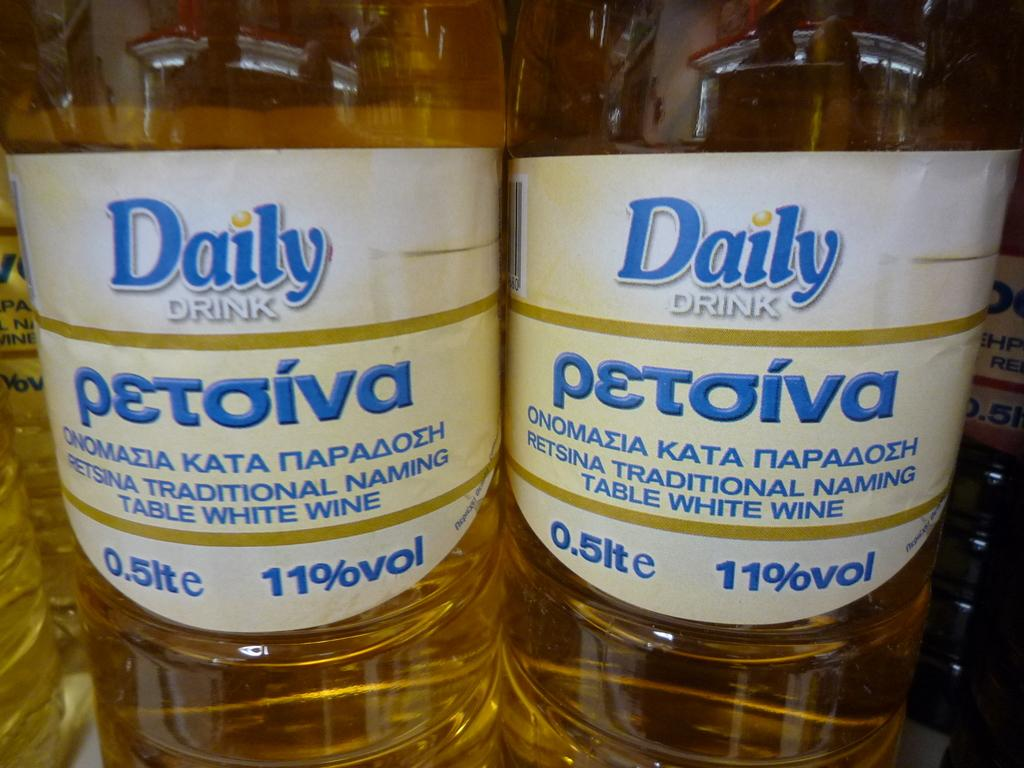<image>
Offer a succinct explanation of the picture presented. Two bottle of Daily drink are next to each other and contain 11% volume. 